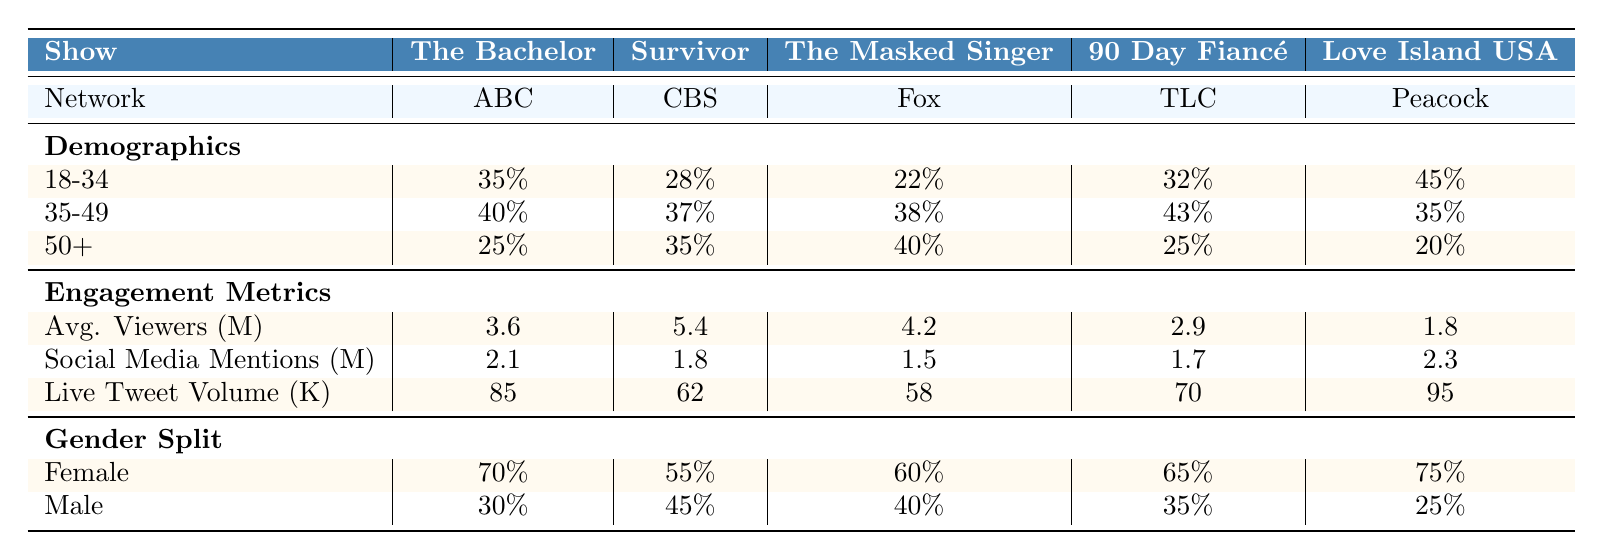What percentage of viewers for "The Bachelor" are aged 18-34? From the demographics section of the table, "The Bachelor" has 35% of its viewers in the 18-34 age group.
Answer: 35% Which show had the highest average viewership in millions? By comparing the "Average Viewers (millions)" for each show, "Survivor" has the highest value at 5.4 million.
Answer: 5.4 Is the majority of the audience for "Love Island USA" female? The gender split indicates that 75% of the audience for "Love Island USA" is female, which confirms that the majority is female.
Answer: Yes What is the total percentage of viewers aged 35-49 across all shows? The percentages for viewers aged 35-49 are: "The Bachelor" (40%), "Survivor" (37%), "The Masked Singer" (38%), "90 Day Fiancé" (43%), and "Love Island USA" (35%). Adding these gives 40 + 37 + 38 + 43 + 35 = 193%.
Answer: 193% Which show has the least engagement in terms of live tweet volume? By looking at the "Live Tweet Volume (thousands)", "Love Island USA" has the lowest value at 95 thousand.
Answer: 95 What is the difference in social media mentions between "The Bachelor" and "The Masked Singer"? "The Bachelor" has 2.1 million social media mentions, while "The Masked Singer" has 1.5 million. The difference is 2.1 - 1.5 = 0.6 million.
Answer: 0.6 million Which show had more male viewers, "Survivor" or "90 Day Fiancé"? "Survivor" has 45% male viewers, while "90 Day Fiancé" has 35%. Therefore, "Survivor" has more male viewers compared to "90 Day Fiancé".
Answer: Survivor What is the average percentage of viewers aged 50+ across all five shows? The percentages for viewers aged 50+ are: "The Bachelor" (25%), "Survivor" (35%), "The Masked Singer" (40%), "90 Day Fiancé" (25%), and "Love Island USA" (20%). Adding these gives 25 + 35 + 40 + 25 + 20 =  145%. Dividing by the number of shows, 145/5 = 29%.
Answer: 29% Which show has the highest percentage of viewers aged 18-34? By examining the "18-34" demographics, "Love Island USA" has the highest percentage with 45%.
Answer: 45% Is the average viewer count for "90 Day Fiancé" higher than the average count for "The Bachelor"? "90 Day Fiancé" has 2.9 million average viewers, while "The Bachelor" has 3.6 million. Since 2.9 is less than 3.6, the average viewer count for "90 Day Fiancé" is not higher than that for "The Bachelor".
Answer: No 